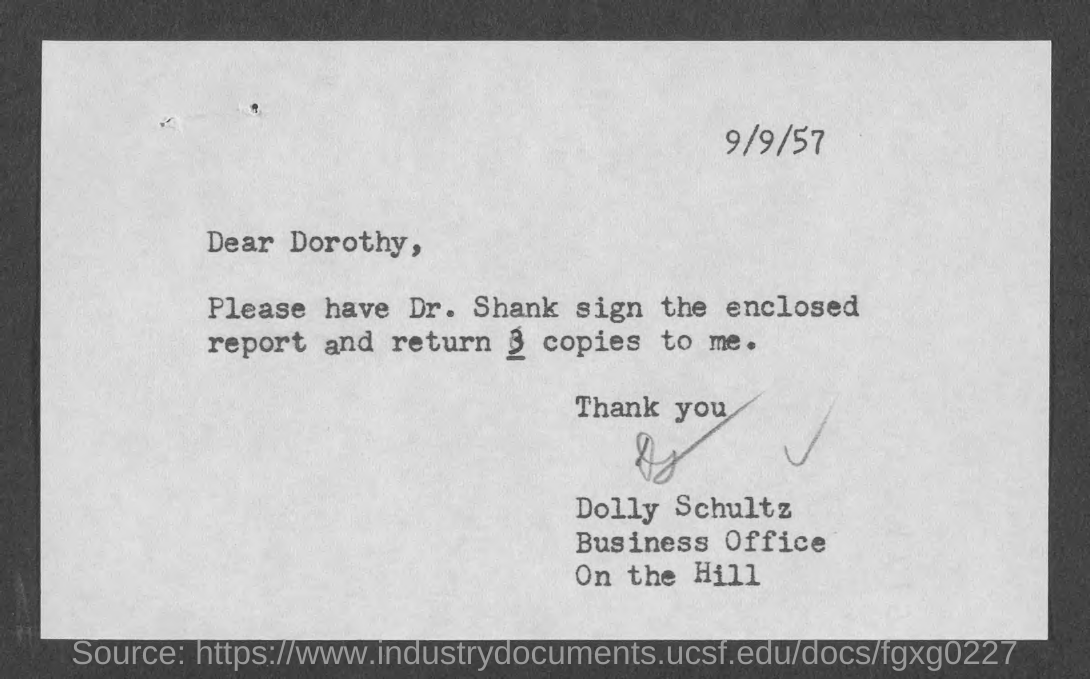When is the document dated?
Provide a succinct answer. 9/9/57. To whom is the letter addressed?
Offer a very short reply. Dorothy. Who is the sender?
Your answer should be compact. Dolly Schultz. How many copies should be returned?
Provide a short and direct response. 3. 